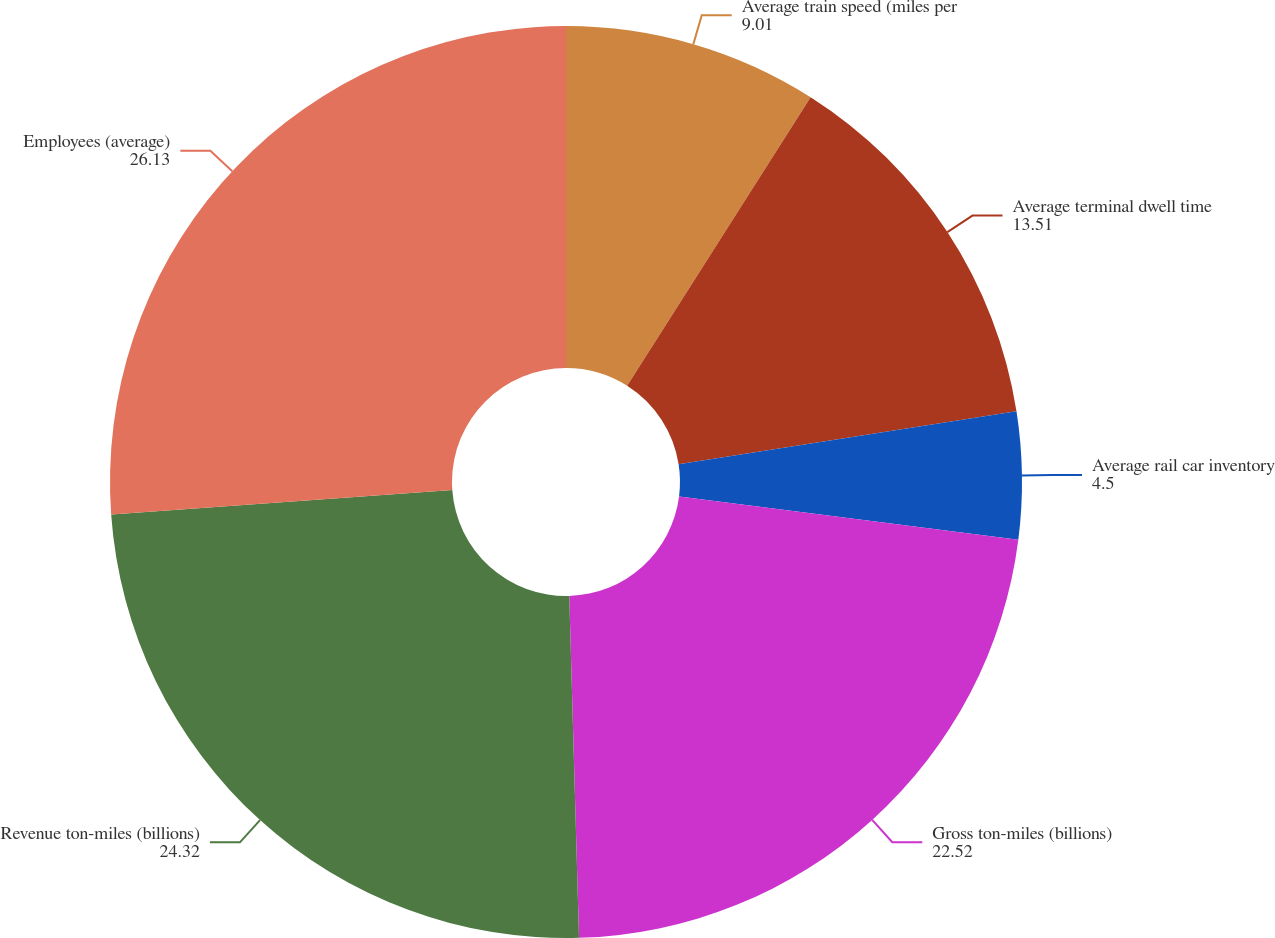Convert chart. <chart><loc_0><loc_0><loc_500><loc_500><pie_chart><fcel>Average train speed (miles per<fcel>Average terminal dwell time<fcel>Average rail car inventory<fcel>Gross ton-miles (billions)<fcel>Revenue ton-miles (billions)<fcel>Employees (average)<nl><fcel>9.01%<fcel>13.51%<fcel>4.5%<fcel>22.52%<fcel>24.32%<fcel>26.13%<nl></chart> 